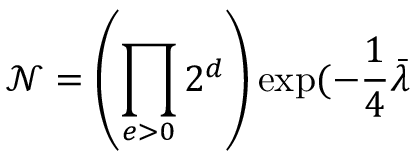Convert formula to latex. <formula><loc_0><loc_0><loc_500><loc_500>\mathcal { N } = \left ( \prod _ { e > 0 } 2 ^ { d } \right ) \exp ( - \frac { 1 } { 4 } \bar { \lambda }</formula> 